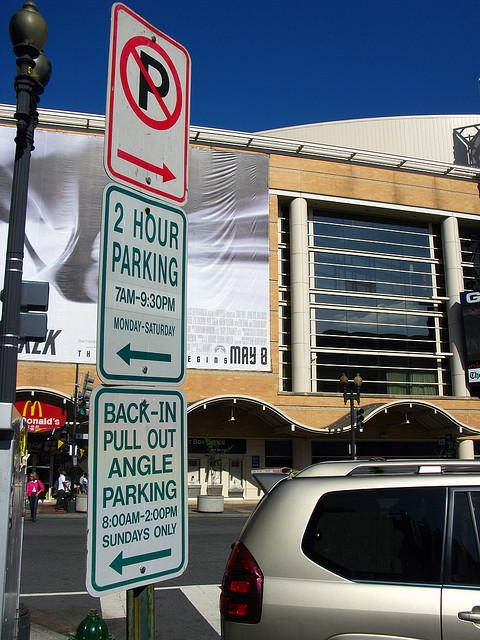The billboard on the building is advertising for which science fiction franchise? star trek 